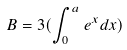<formula> <loc_0><loc_0><loc_500><loc_500>B = 3 ( \int _ { 0 } ^ { a } e ^ { x } d x )</formula> 